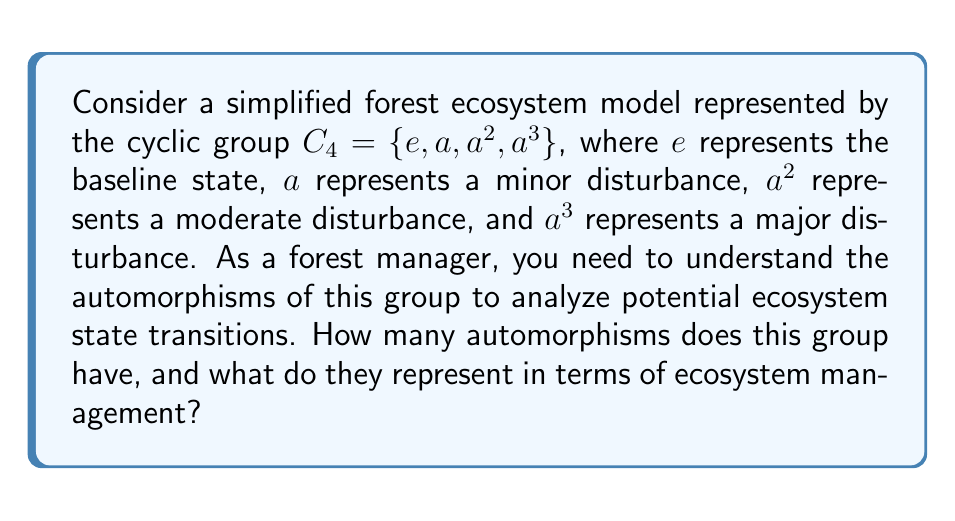What is the answer to this math problem? To solve this problem, we need to follow these steps:

1) First, recall that an automorphism is a bijective homomorphism from a group to itself. For the cyclic group $C_4$, we need to find all possible ways to map the generator $a$ to other elements while preserving the group structure.

2) The order of $a$ is 4, so it must be mapped to an element of order 4. In $C_4$, the elements of order 4 are $a$ and $a^3$.

3) If we map $a$ to $a$, we get the identity automorphism:
   $\phi_1: a \mapsto a$
   This implies: $e \mapsto e$, $a^2 \mapsto a^2$, $a^3 \mapsto a^3$

4) If we map $a$ to $a^3$, we get another automorphism:
   $\phi_2: a \mapsto a^3$
   This implies: $e \mapsto e$, $a^2 \mapsto a^2$, $a^3 \mapsto a$

5) These are the only possible automorphisms of $C_4$.

In terms of ecosystem management:

- $\phi_1$ represents the normal progression of disturbances (minor → moderate → major → baseline).
- $\phi_2$ represents a reversal in the progression of disturbances (minor → major → moderate → baseline).

The number of automorphisms is equal to the number of generators of the group, which is $\phi(4) = 2$, where $\phi$ is Euler's totient function.
Answer: The group $C_4$ has 2 automorphisms. These represent the normal progression and reversal of ecosystem disturbance states, providing insights into possible transition patterns in forest ecosystem management. 